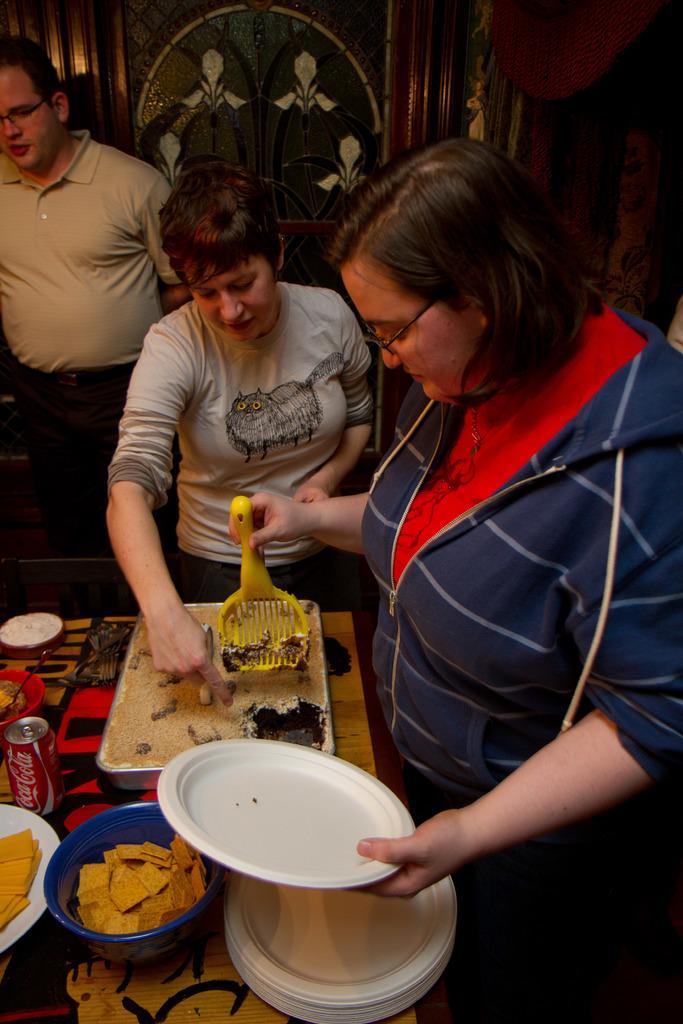Could you give a brief overview of what you see in this image? In the image we can see there are people standing and a woman is holding plates in her hand. There are food items kept in a bowl and in a vessel. 